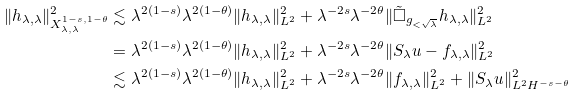<formula> <loc_0><loc_0><loc_500><loc_500>\| h _ { \lambda , \lambda } \| _ { X _ { \lambda , \lambda } ^ { 1 - s , 1 - \theta } } ^ { 2 } \lesssim & \ \lambda ^ { 2 ( 1 - s ) } \lambda ^ { 2 ( 1 - \theta ) } \| h _ { \lambda , \lambda } \| _ { L ^ { 2 } } ^ { 2 } + \lambda ^ { - 2 s } \lambda ^ { - 2 \theta } \| \tilde { \Box } _ { g _ { < \sqrt { \lambda } } } h _ { \lambda , \lambda } \| _ { L ^ { 2 } } ^ { 2 } \\ = & \ \lambda ^ { 2 ( 1 - s ) } \lambda ^ { 2 ( 1 - \theta ) } \| h _ { \lambda , \lambda } \| _ { L ^ { 2 } } ^ { 2 } + \lambda ^ { - 2 s } \lambda ^ { - 2 \theta } \| S _ { \lambda } u - f _ { \lambda , \lambda } \| _ { L ^ { 2 } } ^ { 2 } \\ \lesssim & \ \lambda ^ { 2 ( 1 - s ) } \lambda ^ { 2 ( 1 - \theta ) } \| h _ { \lambda , \lambda } \| _ { L ^ { 2 } } ^ { 2 } + \lambda ^ { - 2 s } \lambda ^ { - 2 \theta } \| f _ { \lambda , \lambda } \| _ { L ^ { 2 } } ^ { 2 } + \| S _ { \lambda } u \| _ { L ^ { 2 } H ^ { - s - \theta } } ^ { 2 }</formula> 